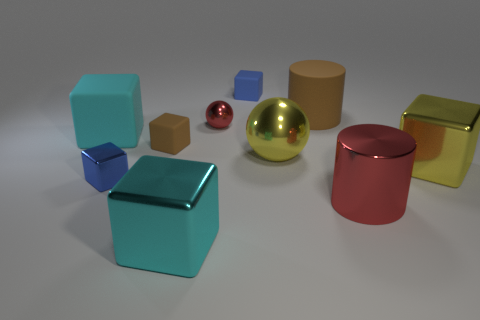Subtract all tiny shiny blocks. How many blocks are left? 5 Subtract all yellow cubes. How many cubes are left? 5 Subtract all brown blocks. Subtract all brown spheres. How many blocks are left? 5 Subtract all balls. How many objects are left? 8 Subtract all tiny yellow metal spheres. Subtract all big brown rubber things. How many objects are left? 9 Add 5 blue matte cubes. How many blue matte cubes are left? 6 Add 4 big metallic spheres. How many big metallic spheres exist? 5 Subtract 0 green cylinders. How many objects are left? 10 